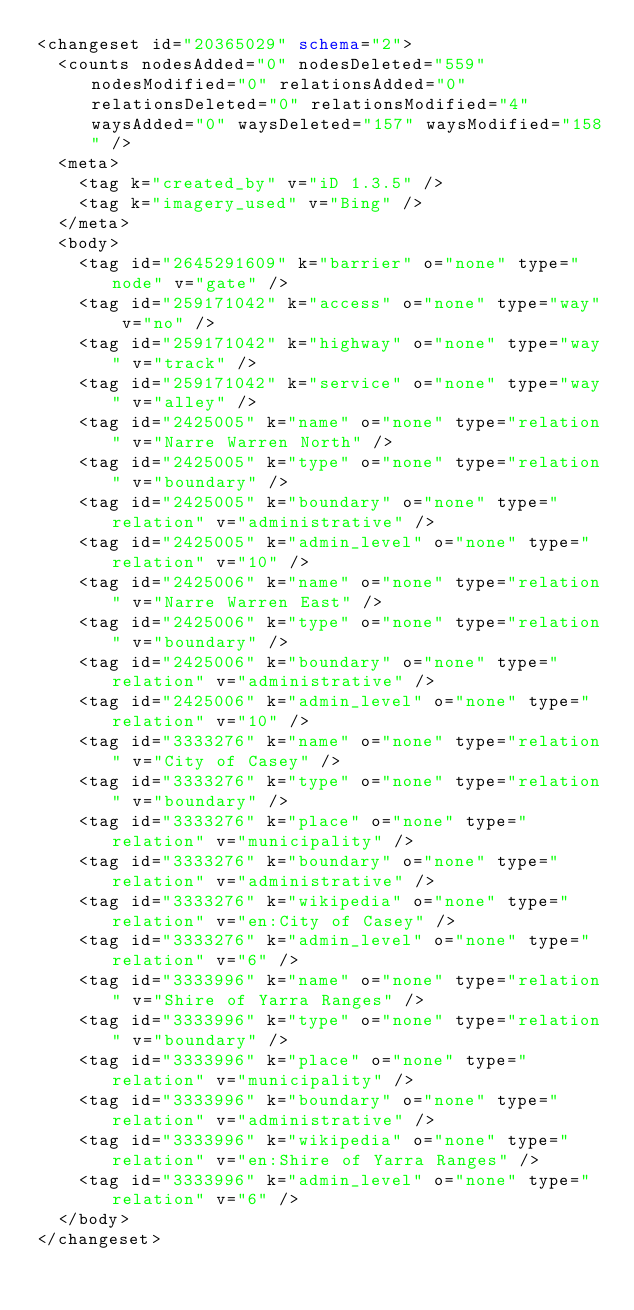Convert code to text. <code><loc_0><loc_0><loc_500><loc_500><_XML_><changeset id="20365029" schema="2">
  <counts nodesAdded="0" nodesDeleted="559" nodesModified="0" relationsAdded="0" relationsDeleted="0" relationsModified="4" waysAdded="0" waysDeleted="157" waysModified="158" />
  <meta>
    <tag k="created_by" v="iD 1.3.5" />
    <tag k="imagery_used" v="Bing" />
  </meta>
  <body>
    <tag id="2645291609" k="barrier" o="none" type="node" v="gate" />
    <tag id="259171042" k="access" o="none" type="way" v="no" />
    <tag id="259171042" k="highway" o="none" type="way" v="track" />
    <tag id="259171042" k="service" o="none" type="way" v="alley" />
    <tag id="2425005" k="name" o="none" type="relation" v="Narre Warren North" />
    <tag id="2425005" k="type" o="none" type="relation" v="boundary" />
    <tag id="2425005" k="boundary" o="none" type="relation" v="administrative" />
    <tag id="2425005" k="admin_level" o="none" type="relation" v="10" />
    <tag id="2425006" k="name" o="none" type="relation" v="Narre Warren East" />
    <tag id="2425006" k="type" o="none" type="relation" v="boundary" />
    <tag id="2425006" k="boundary" o="none" type="relation" v="administrative" />
    <tag id="2425006" k="admin_level" o="none" type="relation" v="10" />
    <tag id="3333276" k="name" o="none" type="relation" v="City of Casey" />
    <tag id="3333276" k="type" o="none" type="relation" v="boundary" />
    <tag id="3333276" k="place" o="none" type="relation" v="municipality" />
    <tag id="3333276" k="boundary" o="none" type="relation" v="administrative" />
    <tag id="3333276" k="wikipedia" o="none" type="relation" v="en:City of Casey" />
    <tag id="3333276" k="admin_level" o="none" type="relation" v="6" />
    <tag id="3333996" k="name" o="none" type="relation" v="Shire of Yarra Ranges" />
    <tag id="3333996" k="type" o="none" type="relation" v="boundary" />
    <tag id="3333996" k="place" o="none" type="relation" v="municipality" />
    <tag id="3333996" k="boundary" o="none" type="relation" v="administrative" />
    <tag id="3333996" k="wikipedia" o="none" type="relation" v="en:Shire of Yarra Ranges" />
    <tag id="3333996" k="admin_level" o="none" type="relation" v="6" />
  </body>
</changeset>
</code> 